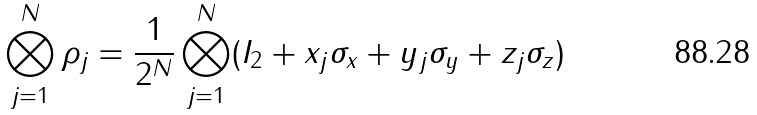Convert formula to latex. <formula><loc_0><loc_0><loc_500><loc_500>\bigotimes ^ { N } _ { j = 1 } \rho _ { j } = \frac { 1 } { 2 ^ { N } } \bigotimes ^ { N } _ { j = 1 } ( I _ { 2 } + x _ { j } \sigma _ { x } + y _ { j } \sigma _ { y } + z _ { j } \sigma _ { z } )</formula> 